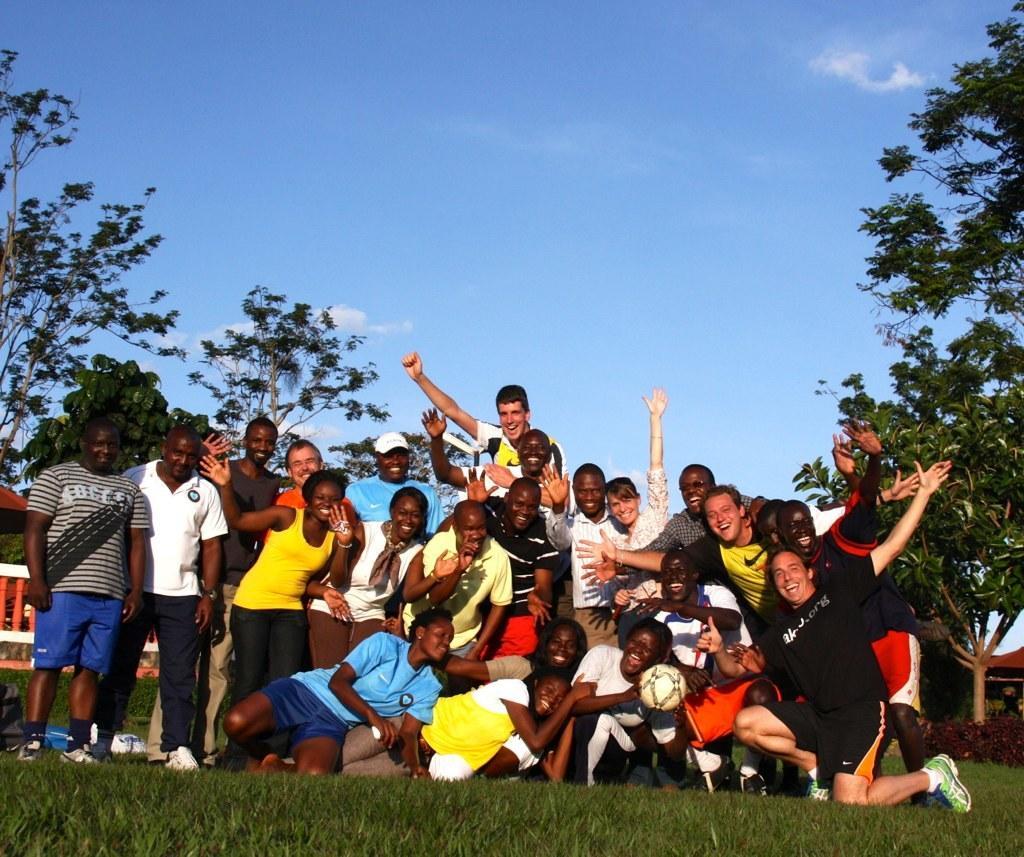Please provide a concise description of this image. In this image we can see many people. There is a person holding ball. On the ground there is grass. In the back there are trees. Also there is a railing. In the background there is sky with clouds. 